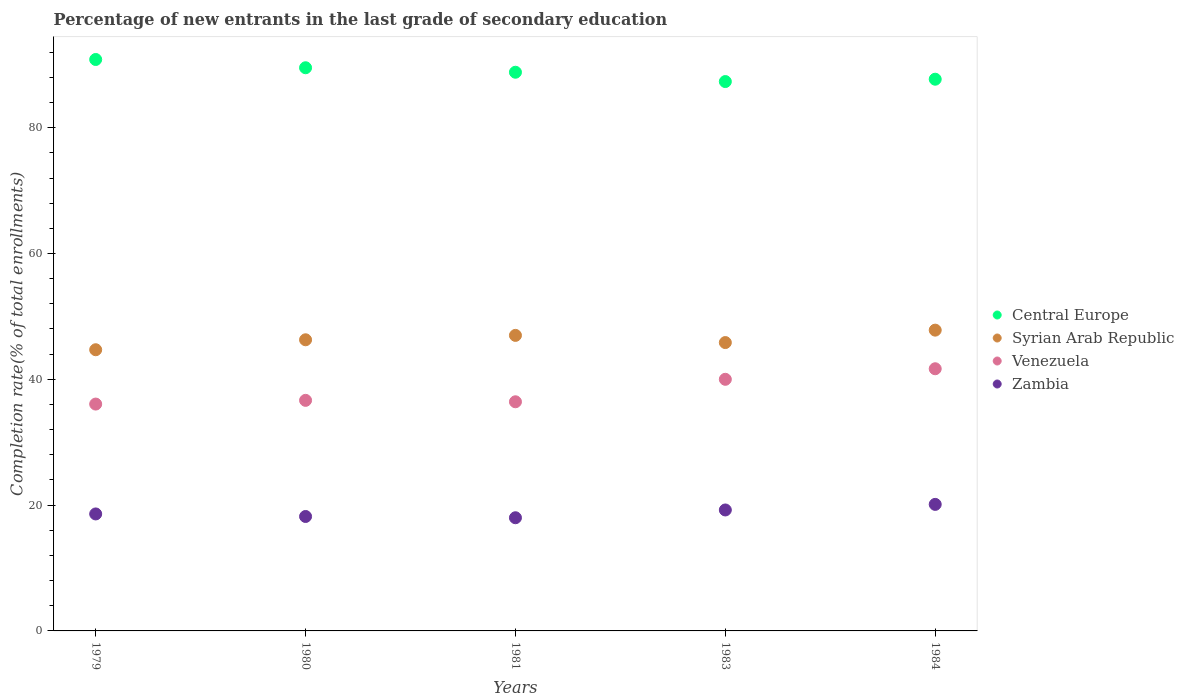How many different coloured dotlines are there?
Your response must be concise. 4. What is the percentage of new entrants in Venezuela in 1984?
Your response must be concise. 41.68. Across all years, what is the maximum percentage of new entrants in Zambia?
Your answer should be very brief. 20.12. Across all years, what is the minimum percentage of new entrants in Venezuela?
Ensure brevity in your answer.  36.06. In which year was the percentage of new entrants in Venezuela maximum?
Your response must be concise. 1984. In which year was the percentage of new entrants in Venezuela minimum?
Keep it short and to the point. 1979. What is the total percentage of new entrants in Central Europe in the graph?
Your answer should be compact. 444.22. What is the difference between the percentage of new entrants in Central Europe in 1980 and that in 1984?
Provide a succinct answer. 1.82. What is the difference between the percentage of new entrants in Syrian Arab Republic in 1984 and the percentage of new entrants in Central Europe in 1981?
Your answer should be very brief. -41. What is the average percentage of new entrants in Central Europe per year?
Make the answer very short. 88.84. In the year 1983, what is the difference between the percentage of new entrants in Zambia and percentage of new entrants in Syrian Arab Republic?
Your answer should be very brief. -26.61. What is the ratio of the percentage of new entrants in Syrian Arab Republic in 1983 to that in 1984?
Offer a very short reply. 0.96. Is the difference between the percentage of new entrants in Zambia in 1980 and 1984 greater than the difference between the percentage of new entrants in Syrian Arab Republic in 1980 and 1984?
Offer a very short reply. No. What is the difference between the highest and the second highest percentage of new entrants in Syrian Arab Republic?
Give a very brief answer. 0.83. What is the difference between the highest and the lowest percentage of new entrants in Central Europe?
Offer a terse response. 3.51. In how many years, is the percentage of new entrants in Zambia greater than the average percentage of new entrants in Zambia taken over all years?
Keep it short and to the point. 2. Is it the case that in every year, the sum of the percentage of new entrants in Zambia and percentage of new entrants in Syrian Arab Republic  is greater than the sum of percentage of new entrants in Venezuela and percentage of new entrants in Central Europe?
Provide a short and direct response. No. Does the percentage of new entrants in Venezuela monotonically increase over the years?
Offer a terse response. No. How many years are there in the graph?
Provide a succinct answer. 5. Does the graph contain any zero values?
Offer a terse response. No. What is the title of the graph?
Ensure brevity in your answer.  Percentage of new entrants in the last grade of secondary education. What is the label or title of the Y-axis?
Ensure brevity in your answer.  Completion rate(% of total enrollments). What is the Completion rate(% of total enrollments) in Central Europe in 1979?
Your response must be concise. 90.84. What is the Completion rate(% of total enrollments) in Syrian Arab Republic in 1979?
Offer a very short reply. 44.7. What is the Completion rate(% of total enrollments) in Venezuela in 1979?
Your response must be concise. 36.06. What is the Completion rate(% of total enrollments) of Zambia in 1979?
Provide a succinct answer. 18.6. What is the Completion rate(% of total enrollments) of Central Europe in 1980?
Make the answer very short. 89.53. What is the Completion rate(% of total enrollments) of Syrian Arab Republic in 1980?
Provide a short and direct response. 46.28. What is the Completion rate(% of total enrollments) of Venezuela in 1980?
Give a very brief answer. 36.65. What is the Completion rate(% of total enrollments) in Zambia in 1980?
Offer a very short reply. 18.19. What is the Completion rate(% of total enrollments) in Central Europe in 1981?
Your answer should be very brief. 88.81. What is the Completion rate(% of total enrollments) of Syrian Arab Republic in 1981?
Keep it short and to the point. 46.98. What is the Completion rate(% of total enrollments) of Venezuela in 1981?
Provide a succinct answer. 36.43. What is the Completion rate(% of total enrollments) in Zambia in 1981?
Your answer should be compact. 17.99. What is the Completion rate(% of total enrollments) of Central Europe in 1983?
Offer a very short reply. 87.33. What is the Completion rate(% of total enrollments) in Syrian Arab Republic in 1983?
Your response must be concise. 45.84. What is the Completion rate(% of total enrollments) of Venezuela in 1983?
Provide a short and direct response. 40. What is the Completion rate(% of total enrollments) in Zambia in 1983?
Keep it short and to the point. 19.23. What is the Completion rate(% of total enrollments) in Central Europe in 1984?
Your answer should be very brief. 87.7. What is the Completion rate(% of total enrollments) of Syrian Arab Republic in 1984?
Ensure brevity in your answer.  47.81. What is the Completion rate(% of total enrollments) in Venezuela in 1984?
Offer a terse response. 41.68. What is the Completion rate(% of total enrollments) of Zambia in 1984?
Offer a terse response. 20.12. Across all years, what is the maximum Completion rate(% of total enrollments) in Central Europe?
Your answer should be compact. 90.84. Across all years, what is the maximum Completion rate(% of total enrollments) in Syrian Arab Republic?
Offer a very short reply. 47.81. Across all years, what is the maximum Completion rate(% of total enrollments) of Venezuela?
Offer a very short reply. 41.68. Across all years, what is the maximum Completion rate(% of total enrollments) in Zambia?
Your answer should be compact. 20.12. Across all years, what is the minimum Completion rate(% of total enrollments) of Central Europe?
Your response must be concise. 87.33. Across all years, what is the minimum Completion rate(% of total enrollments) of Syrian Arab Republic?
Your response must be concise. 44.7. Across all years, what is the minimum Completion rate(% of total enrollments) in Venezuela?
Your response must be concise. 36.06. Across all years, what is the minimum Completion rate(% of total enrollments) in Zambia?
Your response must be concise. 17.99. What is the total Completion rate(% of total enrollments) of Central Europe in the graph?
Offer a very short reply. 444.22. What is the total Completion rate(% of total enrollments) in Syrian Arab Republic in the graph?
Provide a succinct answer. 231.62. What is the total Completion rate(% of total enrollments) of Venezuela in the graph?
Your answer should be compact. 190.82. What is the total Completion rate(% of total enrollments) of Zambia in the graph?
Make the answer very short. 94.12. What is the difference between the Completion rate(% of total enrollments) of Central Europe in 1979 and that in 1980?
Offer a terse response. 1.31. What is the difference between the Completion rate(% of total enrollments) in Syrian Arab Republic in 1979 and that in 1980?
Your answer should be compact. -1.58. What is the difference between the Completion rate(% of total enrollments) in Venezuela in 1979 and that in 1980?
Offer a very short reply. -0.59. What is the difference between the Completion rate(% of total enrollments) in Zambia in 1979 and that in 1980?
Offer a terse response. 0.4. What is the difference between the Completion rate(% of total enrollments) of Central Europe in 1979 and that in 1981?
Provide a succinct answer. 2.03. What is the difference between the Completion rate(% of total enrollments) of Syrian Arab Republic in 1979 and that in 1981?
Provide a succinct answer. -2.28. What is the difference between the Completion rate(% of total enrollments) in Venezuela in 1979 and that in 1981?
Provide a succinct answer. -0.36. What is the difference between the Completion rate(% of total enrollments) in Zambia in 1979 and that in 1981?
Offer a terse response. 0.61. What is the difference between the Completion rate(% of total enrollments) in Central Europe in 1979 and that in 1983?
Offer a very short reply. 3.51. What is the difference between the Completion rate(% of total enrollments) in Syrian Arab Republic in 1979 and that in 1983?
Your response must be concise. -1.14. What is the difference between the Completion rate(% of total enrollments) of Venezuela in 1979 and that in 1983?
Make the answer very short. -3.94. What is the difference between the Completion rate(% of total enrollments) of Zambia in 1979 and that in 1983?
Offer a terse response. -0.63. What is the difference between the Completion rate(% of total enrollments) of Central Europe in 1979 and that in 1984?
Make the answer very short. 3.14. What is the difference between the Completion rate(% of total enrollments) in Syrian Arab Republic in 1979 and that in 1984?
Your answer should be compact. -3.12. What is the difference between the Completion rate(% of total enrollments) of Venezuela in 1979 and that in 1984?
Provide a succinct answer. -5.61. What is the difference between the Completion rate(% of total enrollments) in Zambia in 1979 and that in 1984?
Provide a short and direct response. -1.52. What is the difference between the Completion rate(% of total enrollments) of Central Europe in 1980 and that in 1981?
Give a very brief answer. 0.71. What is the difference between the Completion rate(% of total enrollments) in Syrian Arab Republic in 1980 and that in 1981?
Offer a terse response. -0.7. What is the difference between the Completion rate(% of total enrollments) of Venezuela in 1980 and that in 1981?
Your answer should be very brief. 0.23. What is the difference between the Completion rate(% of total enrollments) in Zambia in 1980 and that in 1981?
Give a very brief answer. 0.2. What is the difference between the Completion rate(% of total enrollments) of Central Europe in 1980 and that in 1983?
Offer a very short reply. 2.19. What is the difference between the Completion rate(% of total enrollments) in Syrian Arab Republic in 1980 and that in 1983?
Give a very brief answer. 0.44. What is the difference between the Completion rate(% of total enrollments) of Venezuela in 1980 and that in 1983?
Your answer should be compact. -3.35. What is the difference between the Completion rate(% of total enrollments) in Zambia in 1980 and that in 1983?
Provide a short and direct response. -1.04. What is the difference between the Completion rate(% of total enrollments) in Central Europe in 1980 and that in 1984?
Provide a short and direct response. 1.82. What is the difference between the Completion rate(% of total enrollments) in Syrian Arab Republic in 1980 and that in 1984?
Your response must be concise. -1.53. What is the difference between the Completion rate(% of total enrollments) in Venezuela in 1980 and that in 1984?
Keep it short and to the point. -5.02. What is the difference between the Completion rate(% of total enrollments) of Zambia in 1980 and that in 1984?
Ensure brevity in your answer.  -1.92. What is the difference between the Completion rate(% of total enrollments) of Central Europe in 1981 and that in 1983?
Your response must be concise. 1.48. What is the difference between the Completion rate(% of total enrollments) of Syrian Arab Republic in 1981 and that in 1983?
Your response must be concise. 1.14. What is the difference between the Completion rate(% of total enrollments) in Venezuela in 1981 and that in 1983?
Provide a short and direct response. -3.57. What is the difference between the Completion rate(% of total enrollments) of Zambia in 1981 and that in 1983?
Your answer should be compact. -1.24. What is the difference between the Completion rate(% of total enrollments) in Central Europe in 1981 and that in 1984?
Offer a very short reply. 1.11. What is the difference between the Completion rate(% of total enrollments) in Syrian Arab Republic in 1981 and that in 1984?
Ensure brevity in your answer.  -0.83. What is the difference between the Completion rate(% of total enrollments) of Venezuela in 1981 and that in 1984?
Your answer should be compact. -5.25. What is the difference between the Completion rate(% of total enrollments) in Zambia in 1981 and that in 1984?
Provide a short and direct response. -2.12. What is the difference between the Completion rate(% of total enrollments) in Central Europe in 1983 and that in 1984?
Offer a very short reply. -0.37. What is the difference between the Completion rate(% of total enrollments) in Syrian Arab Republic in 1983 and that in 1984?
Provide a succinct answer. -1.98. What is the difference between the Completion rate(% of total enrollments) of Venezuela in 1983 and that in 1984?
Offer a very short reply. -1.68. What is the difference between the Completion rate(% of total enrollments) of Zambia in 1983 and that in 1984?
Offer a very short reply. -0.89. What is the difference between the Completion rate(% of total enrollments) of Central Europe in 1979 and the Completion rate(% of total enrollments) of Syrian Arab Republic in 1980?
Your response must be concise. 44.56. What is the difference between the Completion rate(% of total enrollments) of Central Europe in 1979 and the Completion rate(% of total enrollments) of Venezuela in 1980?
Offer a very short reply. 54.19. What is the difference between the Completion rate(% of total enrollments) in Central Europe in 1979 and the Completion rate(% of total enrollments) in Zambia in 1980?
Make the answer very short. 72.65. What is the difference between the Completion rate(% of total enrollments) in Syrian Arab Republic in 1979 and the Completion rate(% of total enrollments) in Venezuela in 1980?
Offer a very short reply. 8.05. What is the difference between the Completion rate(% of total enrollments) in Syrian Arab Republic in 1979 and the Completion rate(% of total enrollments) in Zambia in 1980?
Offer a terse response. 26.51. What is the difference between the Completion rate(% of total enrollments) of Venezuela in 1979 and the Completion rate(% of total enrollments) of Zambia in 1980?
Ensure brevity in your answer.  17.87. What is the difference between the Completion rate(% of total enrollments) of Central Europe in 1979 and the Completion rate(% of total enrollments) of Syrian Arab Republic in 1981?
Your answer should be compact. 43.86. What is the difference between the Completion rate(% of total enrollments) of Central Europe in 1979 and the Completion rate(% of total enrollments) of Venezuela in 1981?
Give a very brief answer. 54.41. What is the difference between the Completion rate(% of total enrollments) in Central Europe in 1979 and the Completion rate(% of total enrollments) in Zambia in 1981?
Provide a short and direct response. 72.85. What is the difference between the Completion rate(% of total enrollments) of Syrian Arab Republic in 1979 and the Completion rate(% of total enrollments) of Venezuela in 1981?
Keep it short and to the point. 8.27. What is the difference between the Completion rate(% of total enrollments) in Syrian Arab Republic in 1979 and the Completion rate(% of total enrollments) in Zambia in 1981?
Provide a short and direct response. 26.71. What is the difference between the Completion rate(% of total enrollments) of Venezuela in 1979 and the Completion rate(% of total enrollments) of Zambia in 1981?
Provide a succinct answer. 18.07. What is the difference between the Completion rate(% of total enrollments) in Central Europe in 1979 and the Completion rate(% of total enrollments) in Syrian Arab Republic in 1983?
Keep it short and to the point. 45. What is the difference between the Completion rate(% of total enrollments) in Central Europe in 1979 and the Completion rate(% of total enrollments) in Venezuela in 1983?
Keep it short and to the point. 50.84. What is the difference between the Completion rate(% of total enrollments) in Central Europe in 1979 and the Completion rate(% of total enrollments) in Zambia in 1983?
Your answer should be very brief. 71.61. What is the difference between the Completion rate(% of total enrollments) of Syrian Arab Republic in 1979 and the Completion rate(% of total enrollments) of Venezuela in 1983?
Provide a succinct answer. 4.7. What is the difference between the Completion rate(% of total enrollments) of Syrian Arab Republic in 1979 and the Completion rate(% of total enrollments) of Zambia in 1983?
Ensure brevity in your answer.  25.47. What is the difference between the Completion rate(% of total enrollments) in Venezuela in 1979 and the Completion rate(% of total enrollments) in Zambia in 1983?
Provide a short and direct response. 16.83. What is the difference between the Completion rate(% of total enrollments) of Central Europe in 1979 and the Completion rate(% of total enrollments) of Syrian Arab Republic in 1984?
Your answer should be compact. 43.03. What is the difference between the Completion rate(% of total enrollments) of Central Europe in 1979 and the Completion rate(% of total enrollments) of Venezuela in 1984?
Your answer should be compact. 49.16. What is the difference between the Completion rate(% of total enrollments) of Central Europe in 1979 and the Completion rate(% of total enrollments) of Zambia in 1984?
Offer a terse response. 70.72. What is the difference between the Completion rate(% of total enrollments) in Syrian Arab Republic in 1979 and the Completion rate(% of total enrollments) in Venezuela in 1984?
Give a very brief answer. 3.02. What is the difference between the Completion rate(% of total enrollments) in Syrian Arab Republic in 1979 and the Completion rate(% of total enrollments) in Zambia in 1984?
Offer a terse response. 24.58. What is the difference between the Completion rate(% of total enrollments) of Venezuela in 1979 and the Completion rate(% of total enrollments) of Zambia in 1984?
Your answer should be compact. 15.95. What is the difference between the Completion rate(% of total enrollments) in Central Europe in 1980 and the Completion rate(% of total enrollments) in Syrian Arab Republic in 1981?
Give a very brief answer. 42.55. What is the difference between the Completion rate(% of total enrollments) of Central Europe in 1980 and the Completion rate(% of total enrollments) of Venezuela in 1981?
Offer a terse response. 53.1. What is the difference between the Completion rate(% of total enrollments) in Central Europe in 1980 and the Completion rate(% of total enrollments) in Zambia in 1981?
Ensure brevity in your answer.  71.54. What is the difference between the Completion rate(% of total enrollments) of Syrian Arab Republic in 1980 and the Completion rate(% of total enrollments) of Venezuela in 1981?
Offer a terse response. 9.86. What is the difference between the Completion rate(% of total enrollments) of Syrian Arab Republic in 1980 and the Completion rate(% of total enrollments) of Zambia in 1981?
Your response must be concise. 28.29. What is the difference between the Completion rate(% of total enrollments) of Venezuela in 1980 and the Completion rate(% of total enrollments) of Zambia in 1981?
Make the answer very short. 18.66. What is the difference between the Completion rate(% of total enrollments) of Central Europe in 1980 and the Completion rate(% of total enrollments) of Syrian Arab Republic in 1983?
Ensure brevity in your answer.  43.69. What is the difference between the Completion rate(% of total enrollments) in Central Europe in 1980 and the Completion rate(% of total enrollments) in Venezuela in 1983?
Ensure brevity in your answer.  49.53. What is the difference between the Completion rate(% of total enrollments) in Central Europe in 1980 and the Completion rate(% of total enrollments) in Zambia in 1983?
Keep it short and to the point. 70.3. What is the difference between the Completion rate(% of total enrollments) of Syrian Arab Republic in 1980 and the Completion rate(% of total enrollments) of Venezuela in 1983?
Provide a short and direct response. 6.28. What is the difference between the Completion rate(% of total enrollments) of Syrian Arab Republic in 1980 and the Completion rate(% of total enrollments) of Zambia in 1983?
Provide a short and direct response. 27.05. What is the difference between the Completion rate(% of total enrollments) of Venezuela in 1980 and the Completion rate(% of total enrollments) of Zambia in 1983?
Make the answer very short. 17.43. What is the difference between the Completion rate(% of total enrollments) of Central Europe in 1980 and the Completion rate(% of total enrollments) of Syrian Arab Republic in 1984?
Provide a succinct answer. 41.71. What is the difference between the Completion rate(% of total enrollments) in Central Europe in 1980 and the Completion rate(% of total enrollments) in Venezuela in 1984?
Your answer should be compact. 47.85. What is the difference between the Completion rate(% of total enrollments) of Central Europe in 1980 and the Completion rate(% of total enrollments) of Zambia in 1984?
Offer a very short reply. 69.41. What is the difference between the Completion rate(% of total enrollments) in Syrian Arab Republic in 1980 and the Completion rate(% of total enrollments) in Venezuela in 1984?
Ensure brevity in your answer.  4.61. What is the difference between the Completion rate(% of total enrollments) of Syrian Arab Republic in 1980 and the Completion rate(% of total enrollments) of Zambia in 1984?
Your answer should be compact. 26.17. What is the difference between the Completion rate(% of total enrollments) in Venezuela in 1980 and the Completion rate(% of total enrollments) in Zambia in 1984?
Provide a short and direct response. 16.54. What is the difference between the Completion rate(% of total enrollments) in Central Europe in 1981 and the Completion rate(% of total enrollments) in Syrian Arab Republic in 1983?
Your response must be concise. 42.97. What is the difference between the Completion rate(% of total enrollments) of Central Europe in 1981 and the Completion rate(% of total enrollments) of Venezuela in 1983?
Offer a very short reply. 48.82. What is the difference between the Completion rate(% of total enrollments) of Central Europe in 1981 and the Completion rate(% of total enrollments) of Zambia in 1983?
Provide a succinct answer. 69.59. What is the difference between the Completion rate(% of total enrollments) in Syrian Arab Republic in 1981 and the Completion rate(% of total enrollments) in Venezuela in 1983?
Provide a short and direct response. 6.98. What is the difference between the Completion rate(% of total enrollments) in Syrian Arab Republic in 1981 and the Completion rate(% of total enrollments) in Zambia in 1983?
Ensure brevity in your answer.  27.75. What is the difference between the Completion rate(% of total enrollments) in Venezuela in 1981 and the Completion rate(% of total enrollments) in Zambia in 1983?
Ensure brevity in your answer.  17.2. What is the difference between the Completion rate(% of total enrollments) of Central Europe in 1981 and the Completion rate(% of total enrollments) of Syrian Arab Republic in 1984?
Your answer should be compact. 41. What is the difference between the Completion rate(% of total enrollments) of Central Europe in 1981 and the Completion rate(% of total enrollments) of Venezuela in 1984?
Ensure brevity in your answer.  47.14. What is the difference between the Completion rate(% of total enrollments) of Central Europe in 1981 and the Completion rate(% of total enrollments) of Zambia in 1984?
Your response must be concise. 68.7. What is the difference between the Completion rate(% of total enrollments) in Syrian Arab Republic in 1981 and the Completion rate(% of total enrollments) in Venezuela in 1984?
Make the answer very short. 5.3. What is the difference between the Completion rate(% of total enrollments) of Syrian Arab Republic in 1981 and the Completion rate(% of total enrollments) of Zambia in 1984?
Give a very brief answer. 26.87. What is the difference between the Completion rate(% of total enrollments) of Venezuela in 1981 and the Completion rate(% of total enrollments) of Zambia in 1984?
Offer a very short reply. 16.31. What is the difference between the Completion rate(% of total enrollments) of Central Europe in 1983 and the Completion rate(% of total enrollments) of Syrian Arab Republic in 1984?
Keep it short and to the point. 39.52. What is the difference between the Completion rate(% of total enrollments) of Central Europe in 1983 and the Completion rate(% of total enrollments) of Venezuela in 1984?
Offer a very short reply. 45.66. What is the difference between the Completion rate(% of total enrollments) of Central Europe in 1983 and the Completion rate(% of total enrollments) of Zambia in 1984?
Give a very brief answer. 67.22. What is the difference between the Completion rate(% of total enrollments) of Syrian Arab Republic in 1983 and the Completion rate(% of total enrollments) of Venezuela in 1984?
Your answer should be compact. 4.16. What is the difference between the Completion rate(% of total enrollments) of Syrian Arab Republic in 1983 and the Completion rate(% of total enrollments) of Zambia in 1984?
Keep it short and to the point. 25.72. What is the difference between the Completion rate(% of total enrollments) of Venezuela in 1983 and the Completion rate(% of total enrollments) of Zambia in 1984?
Make the answer very short. 19.88. What is the average Completion rate(% of total enrollments) in Central Europe per year?
Your response must be concise. 88.84. What is the average Completion rate(% of total enrollments) in Syrian Arab Republic per year?
Ensure brevity in your answer.  46.32. What is the average Completion rate(% of total enrollments) in Venezuela per year?
Offer a very short reply. 38.16. What is the average Completion rate(% of total enrollments) of Zambia per year?
Your answer should be compact. 18.82. In the year 1979, what is the difference between the Completion rate(% of total enrollments) in Central Europe and Completion rate(% of total enrollments) in Syrian Arab Republic?
Offer a terse response. 46.14. In the year 1979, what is the difference between the Completion rate(% of total enrollments) of Central Europe and Completion rate(% of total enrollments) of Venezuela?
Give a very brief answer. 54.78. In the year 1979, what is the difference between the Completion rate(% of total enrollments) of Central Europe and Completion rate(% of total enrollments) of Zambia?
Your answer should be compact. 72.24. In the year 1979, what is the difference between the Completion rate(% of total enrollments) in Syrian Arab Republic and Completion rate(% of total enrollments) in Venezuela?
Give a very brief answer. 8.64. In the year 1979, what is the difference between the Completion rate(% of total enrollments) of Syrian Arab Republic and Completion rate(% of total enrollments) of Zambia?
Ensure brevity in your answer.  26.1. In the year 1979, what is the difference between the Completion rate(% of total enrollments) in Venezuela and Completion rate(% of total enrollments) in Zambia?
Provide a short and direct response. 17.47. In the year 1980, what is the difference between the Completion rate(% of total enrollments) of Central Europe and Completion rate(% of total enrollments) of Syrian Arab Republic?
Offer a terse response. 43.24. In the year 1980, what is the difference between the Completion rate(% of total enrollments) of Central Europe and Completion rate(% of total enrollments) of Venezuela?
Your answer should be compact. 52.87. In the year 1980, what is the difference between the Completion rate(% of total enrollments) in Central Europe and Completion rate(% of total enrollments) in Zambia?
Give a very brief answer. 71.34. In the year 1980, what is the difference between the Completion rate(% of total enrollments) of Syrian Arab Republic and Completion rate(% of total enrollments) of Venezuela?
Provide a succinct answer. 9.63. In the year 1980, what is the difference between the Completion rate(% of total enrollments) of Syrian Arab Republic and Completion rate(% of total enrollments) of Zambia?
Ensure brevity in your answer.  28.09. In the year 1980, what is the difference between the Completion rate(% of total enrollments) in Venezuela and Completion rate(% of total enrollments) in Zambia?
Ensure brevity in your answer.  18.46. In the year 1981, what is the difference between the Completion rate(% of total enrollments) of Central Europe and Completion rate(% of total enrollments) of Syrian Arab Republic?
Provide a short and direct response. 41.83. In the year 1981, what is the difference between the Completion rate(% of total enrollments) in Central Europe and Completion rate(% of total enrollments) in Venezuela?
Provide a short and direct response. 52.39. In the year 1981, what is the difference between the Completion rate(% of total enrollments) of Central Europe and Completion rate(% of total enrollments) of Zambia?
Keep it short and to the point. 70.82. In the year 1981, what is the difference between the Completion rate(% of total enrollments) in Syrian Arab Republic and Completion rate(% of total enrollments) in Venezuela?
Give a very brief answer. 10.55. In the year 1981, what is the difference between the Completion rate(% of total enrollments) in Syrian Arab Republic and Completion rate(% of total enrollments) in Zambia?
Your response must be concise. 28.99. In the year 1981, what is the difference between the Completion rate(% of total enrollments) in Venezuela and Completion rate(% of total enrollments) in Zambia?
Offer a very short reply. 18.44. In the year 1983, what is the difference between the Completion rate(% of total enrollments) in Central Europe and Completion rate(% of total enrollments) in Syrian Arab Republic?
Your answer should be compact. 41.49. In the year 1983, what is the difference between the Completion rate(% of total enrollments) of Central Europe and Completion rate(% of total enrollments) of Venezuela?
Ensure brevity in your answer.  47.33. In the year 1983, what is the difference between the Completion rate(% of total enrollments) in Central Europe and Completion rate(% of total enrollments) in Zambia?
Your response must be concise. 68.1. In the year 1983, what is the difference between the Completion rate(% of total enrollments) of Syrian Arab Republic and Completion rate(% of total enrollments) of Venezuela?
Make the answer very short. 5.84. In the year 1983, what is the difference between the Completion rate(% of total enrollments) in Syrian Arab Republic and Completion rate(% of total enrollments) in Zambia?
Offer a very short reply. 26.61. In the year 1983, what is the difference between the Completion rate(% of total enrollments) of Venezuela and Completion rate(% of total enrollments) of Zambia?
Provide a succinct answer. 20.77. In the year 1984, what is the difference between the Completion rate(% of total enrollments) in Central Europe and Completion rate(% of total enrollments) in Syrian Arab Republic?
Keep it short and to the point. 39.89. In the year 1984, what is the difference between the Completion rate(% of total enrollments) in Central Europe and Completion rate(% of total enrollments) in Venezuela?
Provide a succinct answer. 46.03. In the year 1984, what is the difference between the Completion rate(% of total enrollments) of Central Europe and Completion rate(% of total enrollments) of Zambia?
Offer a very short reply. 67.59. In the year 1984, what is the difference between the Completion rate(% of total enrollments) in Syrian Arab Republic and Completion rate(% of total enrollments) in Venezuela?
Keep it short and to the point. 6.14. In the year 1984, what is the difference between the Completion rate(% of total enrollments) of Syrian Arab Republic and Completion rate(% of total enrollments) of Zambia?
Ensure brevity in your answer.  27.7. In the year 1984, what is the difference between the Completion rate(% of total enrollments) of Venezuela and Completion rate(% of total enrollments) of Zambia?
Your answer should be compact. 21.56. What is the ratio of the Completion rate(% of total enrollments) in Central Europe in 1979 to that in 1980?
Your response must be concise. 1.01. What is the ratio of the Completion rate(% of total enrollments) in Syrian Arab Republic in 1979 to that in 1980?
Your response must be concise. 0.97. What is the ratio of the Completion rate(% of total enrollments) of Venezuela in 1979 to that in 1980?
Ensure brevity in your answer.  0.98. What is the ratio of the Completion rate(% of total enrollments) in Zambia in 1979 to that in 1980?
Your answer should be compact. 1.02. What is the ratio of the Completion rate(% of total enrollments) in Central Europe in 1979 to that in 1981?
Keep it short and to the point. 1.02. What is the ratio of the Completion rate(% of total enrollments) of Syrian Arab Republic in 1979 to that in 1981?
Your answer should be very brief. 0.95. What is the ratio of the Completion rate(% of total enrollments) in Zambia in 1979 to that in 1981?
Give a very brief answer. 1.03. What is the ratio of the Completion rate(% of total enrollments) in Central Europe in 1979 to that in 1983?
Ensure brevity in your answer.  1.04. What is the ratio of the Completion rate(% of total enrollments) in Syrian Arab Republic in 1979 to that in 1983?
Your answer should be compact. 0.98. What is the ratio of the Completion rate(% of total enrollments) in Venezuela in 1979 to that in 1983?
Provide a succinct answer. 0.9. What is the ratio of the Completion rate(% of total enrollments) in Zambia in 1979 to that in 1983?
Give a very brief answer. 0.97. What is the ratio of the Completion rate(% of total enrollments) in Central Europe in 1979 to that in 1984?
Provide a succinct answer. 1.04. What is the ratio of the Completion rate(% of total enrollments) of Syrian Arab Republic in 1979 to that in 1984?
Your response must be concise. 0.93. What is the ratio of the Completion rate(% of total enrollments) in Venezuela in 1979 to that in 1984?
Provide a succinct answer. 0.87. What is the ratio of the Completion rate(% of total enrollments) in Zambia in 1979 to that in 1984?
Provide a succinct answer. 0.92. What is the ratio of the Completion rate(% of total enrollments) in Central Europe in 1980 to that in 1981?
Ensure brevity in your answer.  1.01. What is the ratio of the Completion rate(% of total enrollments) in Syrian Arab Republic in 1980 to that in 1981?
Your response must be concise. 0.99. What is the ratio of the Completion rate(% of total enrollments) of Venezuela in 1980 to that in 1981?
Offer a very short reply. 1.01. What is the ratio of the Completion rate(% of total enrollments) of Zambia in 1980 to that in 1981?
Your response must be concise. 1.01. What is the ratio of the Completion rate(% of total enrollments) of Central Europe in 1980 to that in 1983?
Your answer should be compact. 1.03. What is the ratio of the Completion rate(% of total enrollments) in Syrian Arab Republic in 1980 to that in 1983?
Offer a terse response. 1.01. What is the ratio of the Completion rate(% of total enrollments) of Venezuela in 1980 to that in 1983?
Provide a succinct answer. 0.92. What is the ratio of the Completion rate(% of total enrollments) in Zambia in 1980 to that in 1983?
Make the answer very short. 0.95. What is the ratio of the Completion rate(% of total enrollments) in Central Europe in 1980 to that in 1984?
Make the answer very short. 1.02. What is the ratio of the Completion rate(% of total enrollments) in Syrian Arab Republic in 1980 to that in 1984?
Give a very brief answer. 0.97. What is the ratio of the Completion rate(% of total enrollments) in Venezuela in 1980 to that in 1984?
Provide a succinct answer. 0.88. What is the ratio of the Completion rate(% of total enrollments) of Zambia in 1980 to that in 1984?
Provide a short and direct response. 0.9. What is the ratio of the Completion rate(% of total enrollments) in Central Europe in 1981 to that in 1983?
Your answer should be very brief. 1.02. What is the ratio of the Completion rate(% of total enrollments) in Syrian Arab Republic in 1981 to that in 1983?
Provide a short and direct response. 1.02. What is the ratio of the Completion rate(% of total enrollments) of Venezuela in 1981 to that in 1983?
Offer a terse response. 0.91. What is the ratio of the Completion rate(% of total enrollments) of Zambia in 1981 to that in 1983?
Your answer should be compact. 0.94. What is the ratio of the Completion rate(% of total enrollments) of Central Europe in 1981 to that in 1984?
Provide a succinct answer. 1.01. What is the ratio of the Completion rate(% of total enrollments) of Syrian Arab Republic in 1981 to that in 1984?
Ensure brevity in your answer.  0.98. What is the ratio of the Completion rate(% of total enrollments) in Venezuela in 1981 to that in 1984?
Your answer should be very brief. 0.87. What is the ratio of the Completion rate(% of total enrollments) in Zambia in 1981 to that in 1984?
Your answer should be very brief. 0.89. What is the ratio of the Completion rate(% of total enrollments) in Syrian Arab Republic in 1983 to that in 1984?
Keep it short and to the point. 0.96. What is the ratio of the Completion rate(% of total enrollments) in Venezuela in 1983 to that in 1984?
Provide a succinct answer. 0.96. What is the ratio of the Completion rate(% of total enrollments) in Zambia in 1983 to that in 1984?
Offer a very short reply. 0.96. What is the difference between the highest and the second highest Completion rate(% of total enrollments) of Central Europe?
Offer a terse response. 1.31. What is the difference between the highest and the second highest Completion rate(% of total enrollments) in Syrian Arab Republic?
Give a very brief answer. 0.83. What is the difference between the highest and the second highest Completion rate(% of total enrollments) in Venezuela?
Offer a terse response. 1.68. What is the difference between the highest and the second highest Completion rate(% of total enrollments) of Zambia?
Keep it short and to the point. 0.89. What is the difference between the highest and the lowest Completion rate(% of total enrollments) of Central Europe?
Keep it short and to the point. 3.51. What is the difference between the highest and the lowest Completion rate(% of total enrollments) of Syrian Arab Republic?
Ensure brevity in your answer.  3.12. What is the difference between the highest and the lowest Completion rate(% of total enrollments) of Venezuela?
Give a very brief answer. 5.61. What is the difference between the highest and the lowest Completion rate(% of total enrollments) of Zambia?
Ensure brevity in your answer.  2.12. 